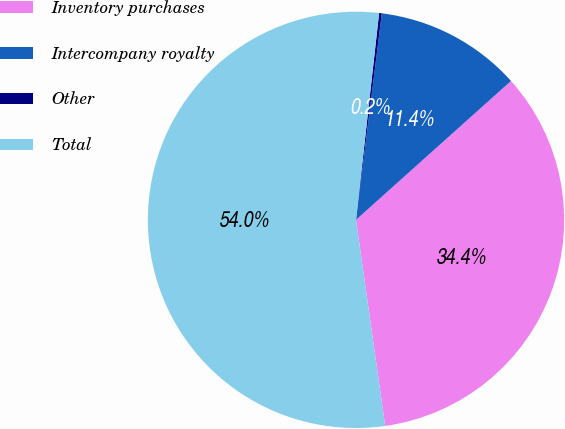<chart> <loc_0><loc_0><loc_500><loc_500><pie_chart><fcel>Inventory purchases<fcel>Intercompany royalty<fcel>Other<fcel>Total<nl><fcel>34.39%<fcel>11.39%<fcel>0.21%<fcel>54.01%<nl></chart> 